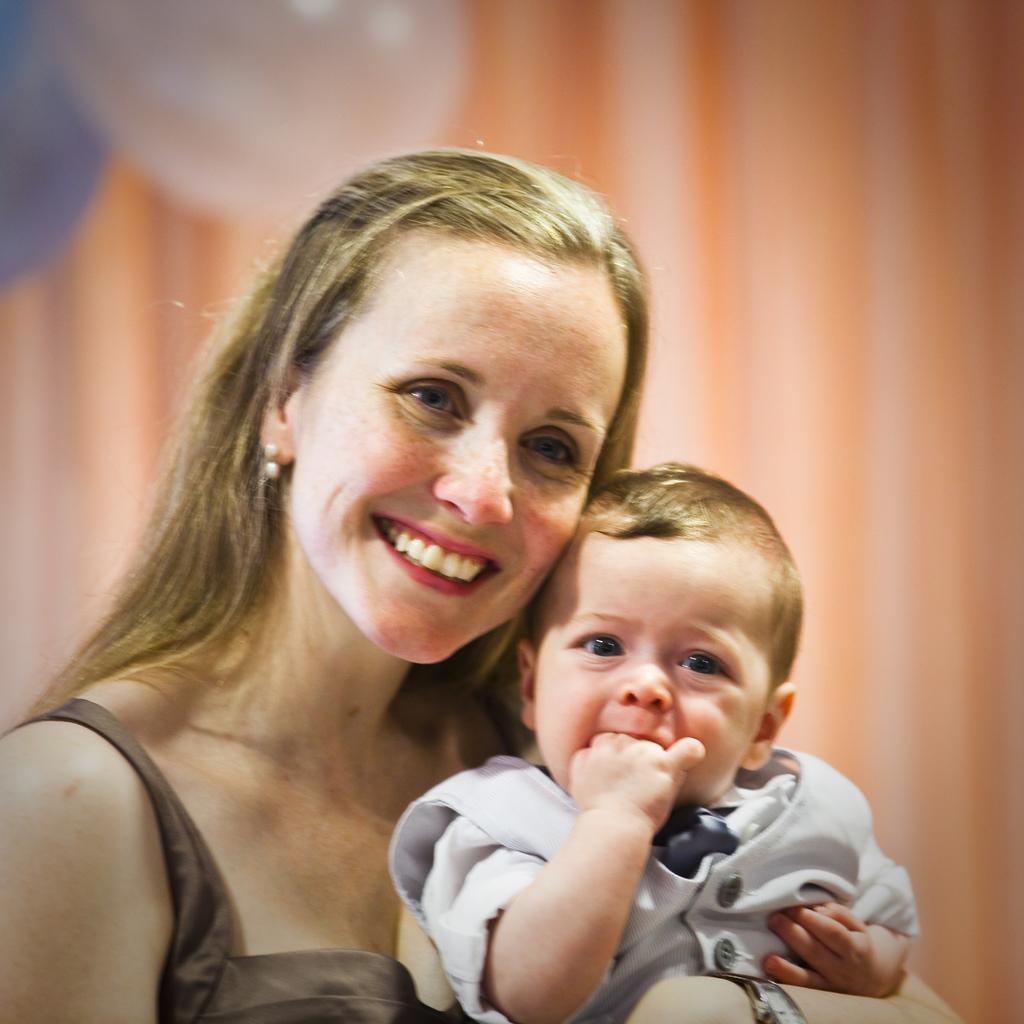In one or two sentences, can you explain what this image depicts? Here we can see a woman holding a kid in her hand and she is smiling. In the background we can see two balloons and a curtain. 